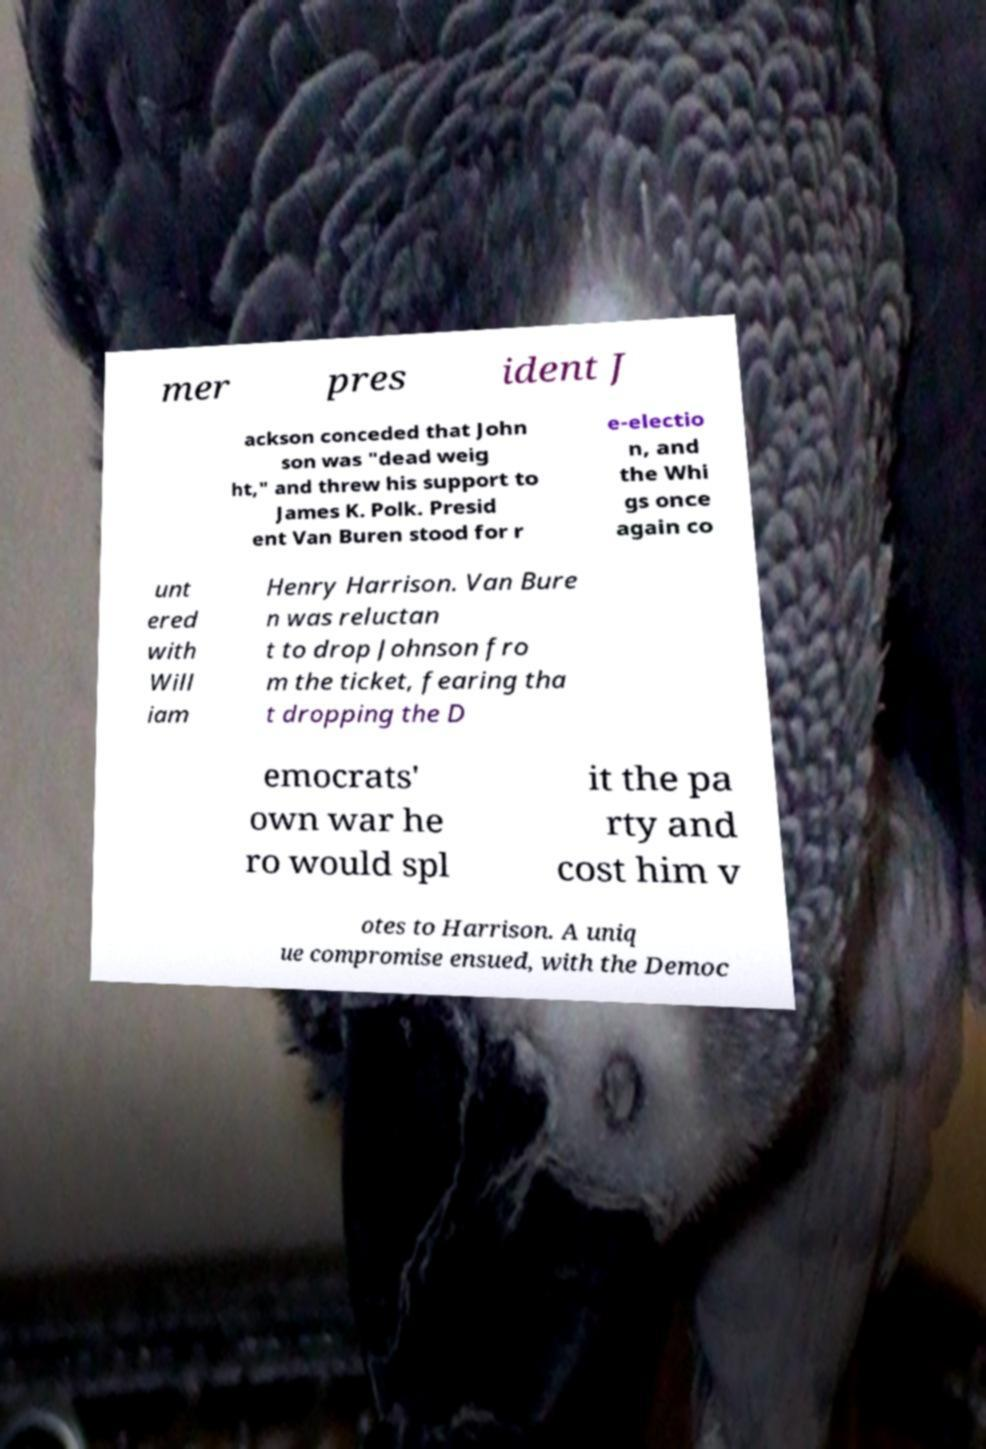For documentation purposes, I need the text within this image transcribed. Could you provide that? mer pres ident J ackson conceded that John son was "dead weig ht," and threw his support to James K. Polk. Presid ent Van Buren stood for r e-electio n, and the Whi gs once again co unt ered with Will iam Henry Harrison. Van Bure n was reluctan t to drop Johnson fro m the ticket, fearing tha t dropping the D emocrats' own war he ro would spl it the pa rty and cost him v otes to Harrison. A uniq ue compromise ensued, with the Democ 